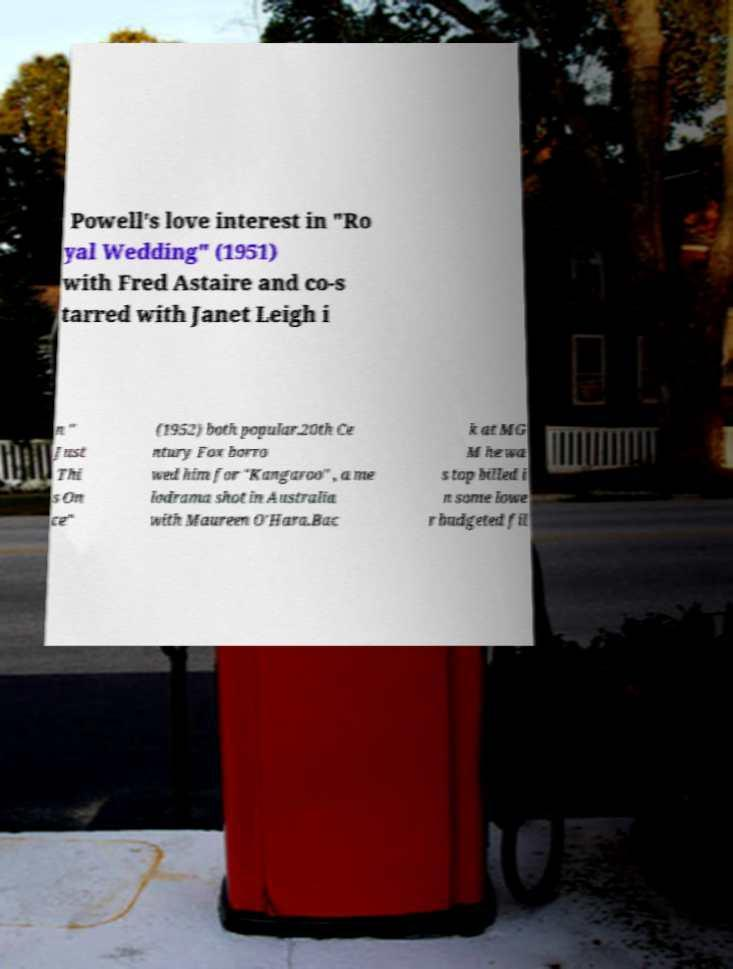Could you extract and type out the text from this image? Powell's love interest in "Ro yal Wedding" (1951) with Fred Astaire and co-s tarred with Janet Leigh i n " Just Thi s On ce" (1952) both popular.20th Ce ntury Fox borro wed him for "Kangaroo" , a me lodrama shot in Australia with Maureen O'Hara.Bac k at MG M he wa s top billed i n some lowe r budgeted fil 